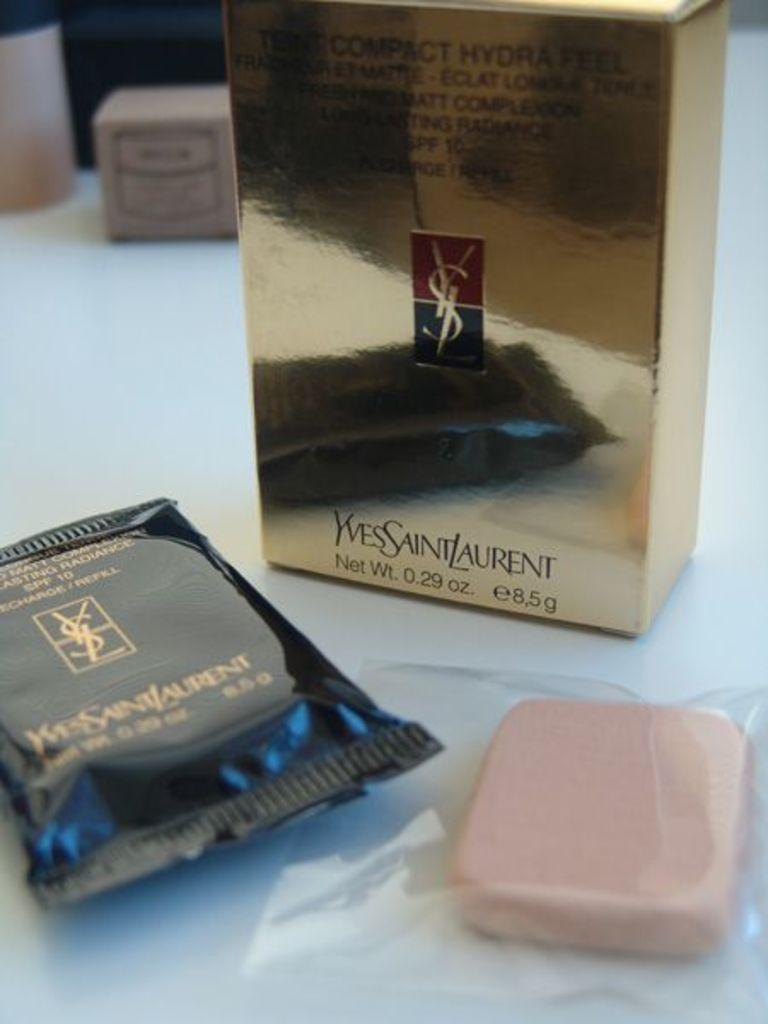<image>
Relay a brief, clear account of the picture shown. A YVESSAINTLAURENT box with soap is presented on the counter. 